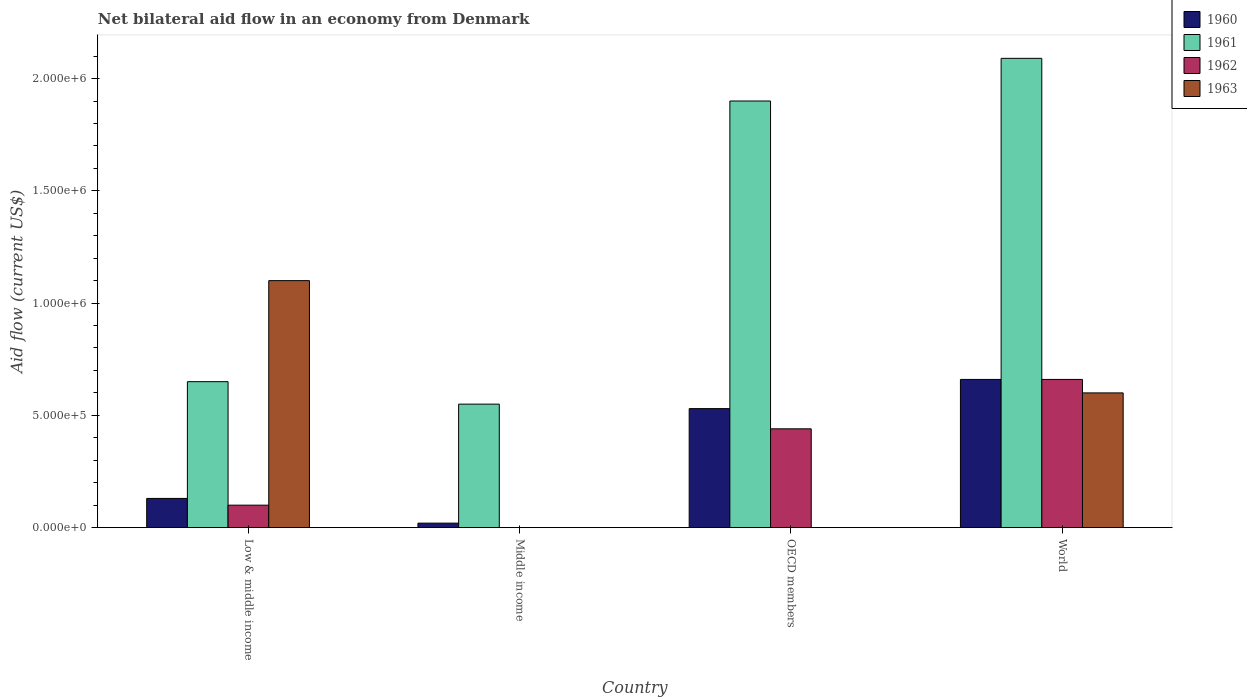Are the number of bars on each tick of the X-axis equal?
Offer a terse response. No. What is the label of the 3rd group of bars from the left?
Ensure brevity in your answer.  OECD members. Across all countries, what is the maximum net bilateral aid flow in 1960?
Your response must be concise. 6.60e+05. What is the total net bilateral aid flow in 1960 in the graph?
Provide a succinct answer. 1.34e+06. What is the difference between the net bilateral aid flow in 1962 in Low & middle income and that in World?
Give a very brief answer. -5.60e+05. What is the difference between the net bilateral aid flow in 1963 in Low & middle income and the net bilateral aid flow in 1961 in Middle income?
Offer a terse response. 5.50e+05. What is the average net bilateral aid flow in 1961 per country?
Provide a short and direct response. 1.30e+06. What is the difference between the net bilateral aid flow of/in 1963 and net bilateral aid flow of/in 1960 in Low & middle income?
Offer a terse response. 9.70e+05. In how many countries, is the net bilateral aid flow in 1961 greater than 800000 US$?
Make the answer very short. 2. What is the ratio of the net bilateral aid flow in 1961 in Low & middle income to that in Middle income?
Your answer should be compact. 1.18. Is the net bilateral aid flow in 1961 in Middle income less than that in World?
Offer a very short reply. Yes. Is the difference between the net bilateral aid flow in 1963 in Low & middle income and World greater than the difference between the net bilateral aid flow in 1960 in Low & middle income and World?
Keep it short and to the point. Yes. What is the difference between the highest and the lowest net bilateral aid flow in 1961?
Keep it short and to the point. 1.54e+06. In how many countries, is the net bilateral aid flow in 1963 greater than the average net bilateral aid flow in 1963 taken over all countries?
Provide a short and direct response. 2. Are all the bars in the graph horizontal?
Provide a succinct answer. No. How many countries are there in the graph?
Keep it short and to the point. 4. What is the difference between two consecutive major ticks on the Y-axis?
Keep it short and to the point. 5.00e+05. Does the graph contain any zero values?
Give a very brief answer. Yes. Does the graph contain grids?
Your answer should be compact. No. What is the title of the graph?
Provide a short and direct response. Net bilateral aid flow in an economy from Denmark. Does "1962" appear as one of the legend labels in the graph?
Your answer should be compact. Yes. What is the label or title of the X-axis?
Make the answer very short. Country. What is the label or title of the Y-axis?
Provide a short and direct response. Aid flow (current US$). What is the Aid flow (current US$) in 1961 in Low & middle income?
Give a very brief answer. 6.50e+05. What is the Aid flow (current US$) in 1962 in Low & middle income?
Provide a succinct answer. 1.00e+05. What is the Aid flow (current US$) of 1963 in Low & middle income?
Offer a terse response. 1.10e+06. What is the Aid flow (current US$) of 1961 in Middle income?
Offer a very short reply. 5.50e+05. What is the Aid flow (current US$) of 1962 in Middle income?
Your answer should be very brief. 0. What is the Aid flow (current US$) of 1960 in OECD members?
Give a very brief answer. 5.30e+05. What is the Aid flow (current US$) in 1961 in OECD members?
Offer a terse response. 1.90e+06. What is the Aid flow (current US$) of 1962 in OECD members?
Give a very brief answer. 4.40e+05. What is the Aid flow (current US$) of 1963 in OECD members?
Make the answer very short. 0. What is the Aid flow (current US$) in 1960 in World?
Ensure brevity in your answer.  6.60e+05. What is the Aid flow (current US$) in 1961 in World?
Provide a succinct answer. 2.09e+06. What is the Aid flow (current US$) in 1962 in World?
Your answer should be very brief. 6.60e+05. What is the Aid flow (current US$) in 1963 in World?
Give a very brief answer. 6.00e+05. Across all countries, what is the maximum Aid flow (current US$) in 1960?
Your answer should be very brief. 6.60e+05. Across all countries, what is the maximum Aid flow (current US$) of 1961?
Keep it short and to the point. 2.09e+06. Across all countries, what is the maximum Aid flow (current US$) in 1962?
Give a very brief answer. 6.60e+05. Across all countries, what is the maximum Aid flow (current US$) of 1963?
Offer a very short reply. 1.10e+06. Across all countries, what is the minimum Aid flow (current US$) in 1961?
Offer a very short reply. 5.50e+05. Across all countries, what is the minimum Aid flow (current US$) in 1962?
Provide a succinct answer. 0. What is the total Aid flow (current US$) of 1960 in the graph?
Provide a succinct answer. 1.34e+06. What is the total Aid flow (current US$) in 1961 in the graph?
Keep it short and to the point. 5.19e+06. What is the total Aid flow (current US$) of 1962 in the graph?
Give a very brief answer. 1.20e+06. What is the total Aid flow (current US$) of 1963 in the graph?
Provide a short and direct response. 1.70e+06. What is the difference between the Aid flow (current US$) in 1961 in Low & middle income and that in Middle income?
Your answer should be compact. 1.00e+05. What is the difference between the Aid flow (current US$) in 1960 in Low & middle income and that in OECD members?
Offer a very short reply. -4.00e+05. What is the difference between the Aid flow (current US$) of 1961 in Low & middle income and that in OECD members?
Your response must be concise. -1.25e+06. What is the difference between the Aid flow (current US$) of 1962 in Low & middle income and that in OECD members?
Give a very brief answer. -3.40e+05. What is the difference between the Aid flow (current US$) of 1960 in Low & middle income and that in World?
Your response must be concise. -5.30e+05. What is the difference between the Aid flow (current US$) in 1961 in Low & middle income and that in World?
Provide a succinct answer. -1.44e+06. What is the difference between the Aid flow (current US$) of 1962 in Low & middle income and that in World?
Ensure brevity in your answer.  -5.60e+05. What is the difference between the Aid flow (current US$) in 1960 in Middle income and that in OECD members?
Your answer should be compact. -5.10e+05. What is the difference between the Aid flow (current US$) in 1961 in Middle income and that in OECD members?
Keep it short and to the point. -1.35e+06. What is the difference between the Aid flow (current US$) of 1960 in Middle income and that in World?
Keep it short and to the point. -6.40e+05. What is the difference between the Aid flow (current US$) in 1961 in Middle income and that in World?
Offer a very short reply. -1.54e+06. What is the difference between the Aid flow (current US$) in 1961 in OECD members and that in World?
Provide a succinct answer. -1.90e+05. What is the difference between the Aid flow (current US$) in 1962 in OECD members and that in World?
Ensure brevity in your answer.  -2.20e+05. What is the difference between the Aid flow (current US$) of 1960 in Low & middle income and the Aid flow (current US$) of 1961 in Middle income?
Offer a terse response. -4.20e+05. What is the difference between the Aid flow (current US$) of 1960 in Low & middle income and the Aid flow (current US$) of 1961 in OECD members?
Make the answer very short. -1.77e+06. What is the difference between the Aid flow (current US$) in 1960 in Low & middle income and the Aid flow (current US$) in 1962 in OECD members?
Provide a succinct answer. -3.10e+05. What is the difference between the Aid flow (current US$) in 1960 in Low & middle income and the Aid flow (current US$) in 1961 in World?
Provide a succinct answer. -1.96e+06. What is the difference between the Aid flow (current US$) of 1960 in Low & middle income and the Aid flow (current US$) of 1962 in World?
Give a very brief answer. -5.30e+05. What is the difference between the Aid flow (current US$) of 1960 in Low & middle income and the Aid flow (current US$) of 1963 in World?
Offer a very short reply. -4.70e+05. What is the difference between the Aid flow (current US$) of 1961 in Low & middle income and the Aid flow (current US$) of 1963 in World?
Provide a succinct answer. 5.00e+04. What is the difference between the Aid flow (current US$) of 1962 in Low & middle income and the Aid flow (current US$) of 1963 in World?
Provide a succinct answer. -5.00e+05. What is the difference between the Aid flow (current US$) in 1960 in Middle income and the Aid flow (current US$) in 1961 in OECD members?
Offer a very short reply. -1.88e+06. What is the difference between the Aid flow (current US$) in 1960 in Middle income and the Aid flow (current US$) in 1962 in OECD members?
Give a very brief answer. -4.20e+05. What is the difference between the Aid flow (current US$) of 1960 in Middle income and the Aid flow (current US$) of 1961 in World?
Keep it short and to the point. -2.07e+06. What is the difference between the Aid flow (current US$) in 1960 in Middle income and the Aid flow (current US$) in 1962 in World?
Provide a short and direct response. -6.40e+05. What is the difference between the Aid flow (current US$) of 1960 in Middle income and the Aid flow (current US$) of 1963 in World?
Your answer should be very brief. -5.80e+05. What is the difference between the Aid flow (current US$) in 1960 in OECD members and the Aid flow (current US$) in 1961 in World?
Keep it short and to the point. -1.56e+06. What is the difference between the Aid flow (current US$) of 1960 in OECD members and the Aid flow (current US$) of 1963 in World?
Give a very brief answer. -7.00e+04. What is the difference between the Aid flow (current US$) in 1961 in OECD members and the Aid flow (current US$) in 1962 in World?
Ensure brevity in your answer.  1.24e+06. What is the difference between the Aid flow (current US$) of 1961 in OECD members and the Aid flow (current US$) of 1963 in World?
Your answer should be compact. 1.30e+06. What is the difference between the Aid flow (current US$) in 1962 in OECD members and the Aid flow (current US$) in 1963 in World?
Your response must be concise. -1.60e+05. What is the average Aid flow (current US$) in 1960 per country?
Give a very brief answer. 3.35e+05. What is the average Aid flow (current US$) in 1961 per country?
Provide a succinct answer. 1.30e+06. What is the average Aid flow (current US$) of 1963 per country?
Your answer should be compact. 4.25e+05. What is the difference between the Aid flow (current US$) of 1960 and Aid flow (current US$) of 1961 in Low & middle income?
Your answer should be compact. -5.20e+05. What is the difference between the Aid flow (current US$) of 1960 and Aid flow (current US$) of 1963 in Low & middle income?
Your answer should be compact. -9.70e+05. What is the difference between the Aid flow (current US$) in 1961 and Aid flow (current US$) in 1963 in Low & middle income?
Your answer should be very brief. -4.50e+05. What is the difference between the Aid flow (current US$) in 1962 and Aid flow (current US$) in 1963 in Low & middle income?
Your response must be concise. -1.00e+06. What is the difference between the Aid flow (current US$) in 1960 and Aid flow (current US$) in 1961 in Middle income?
Offer a terse response. -5.30e+05. What is the difference between the Aid flow (current US$) of 1960 and Aid flow (current US$) of 1961 in OECD members?
Offer a terse response. -1.37e+06. What is the difference between the Aid flow (current US$) of 1961 and Aid flow (current US$) of 1962 in OECD members?
Make the answer very short. 1.46e+06. What is the difference between the Aid flow (current US$) in 1960 and Aid flow (current US$) in 1961 in World?
Ensure brevity in your answer.  -1.43e+06. What is the difference between the Aid flow (current US$) of 1960 and Aid flow (current US$) of 1963 in World?
Offer a very short reply. 6.00e+04. What is the difference between the Aid flow (current US$) of 1961 and Aid flow (current US$) of 1962 in World?
Your answer should be very brief. 1.43e+06. What is the difference between the Aid flow (current US$) of 1961 and Aid flow (current US$) of 1963 in World?
Offer a very short reply. 1.49e+06. What is the difference between the Aid flow (current US$) in 1962 and Aid flow (current US$) in 1963 in World?
Your response must be concise. 6.00e+04. What is the ratio of the Aid flow (current US$) in 1961 in Low & middle income to that in Middle income?
Ensure brevity in your answer.  1.18. What is the ratio of the Aid flow (current US$) of 1960 in Low & middle income to that in OECD members?
Provide a short and direct response. 0.25. What is the ratio of the Aid flow (current US$) of 1961 in Low & middle income to that in OECD members?
Provide a succinct answer. 0.34. What is the ratio of the Aid flow (current US$) in 1962 in Low & middle income to that in OECD members?
Your answer should be compact. 0.23. What is the ratio of the Aid flow (current US$) of 1960 in Low & middle income to that in World?
Your answer should be compact. 0.2. What is the ratio of the Aid flow (current US$) in 1961 in Low & middle income to that in World?
Keep it short and to the point. 0.31. What is the ratio of the Aid flow (current US$) of 1962 in Low & middle income to that in World?
Provide a succinct answer. 0.15. What is the ratio of the Aid flow (current US$) of 1963 in Low & middle income to that in World?
Your response must be concise. 1.83. What is the ratio of the Aid flow (current US$) of 1960 in Middle income to that in OECD members?
Offer a terse response. 0.04. What is the ratio of the Aid flow (current US$) in 1961 in Middle income to that in OECD members?
Keep it short and to the point. 0.29. What is the ratio of the Aid flow (current US$) in 1960 in Middle income to that in World?
Provide a succinct answer. 0.03. What is the ratio of the Aid flow (current US$) of 1961 in Middle income to that in World?
Give a very brief answer. 0.26. What is the ratio of the Aid flow (current US$) in 1960 in OECD members to that in World?
Offer a terse response. 0.8. What is the difference between the highest and the second highest Aid flow (current US$) in 1960?
Provide a succinct answer. 1.30e+05. What is the difference between the highest and the second highest Aid flow (current US$) of 1961?
Make the answer very short. 1.90e+05. What is the difference between the highest and the second highest Aid flow (current US$) in 1962?
Ensure brevity in your answer.  2.20e+05. What is the difference between the highest and the lowest Aid flow (current US$) of 1960?
Keep it short and to the point. 6.40e+05. What is the difference between the highest and the lowest Aid flow (current US$) of 1961?
Provide a succinct answer. 1.54e+06. What is the difference between the highest and the lowest Aid flow (current US$) in 1962?
Ensure brevity in your answer.  6.60e+05. What is the difference between the highest and the lowest Aid flow (current US$) of 1963?
Your answer should be compact. 1.10e+06. 